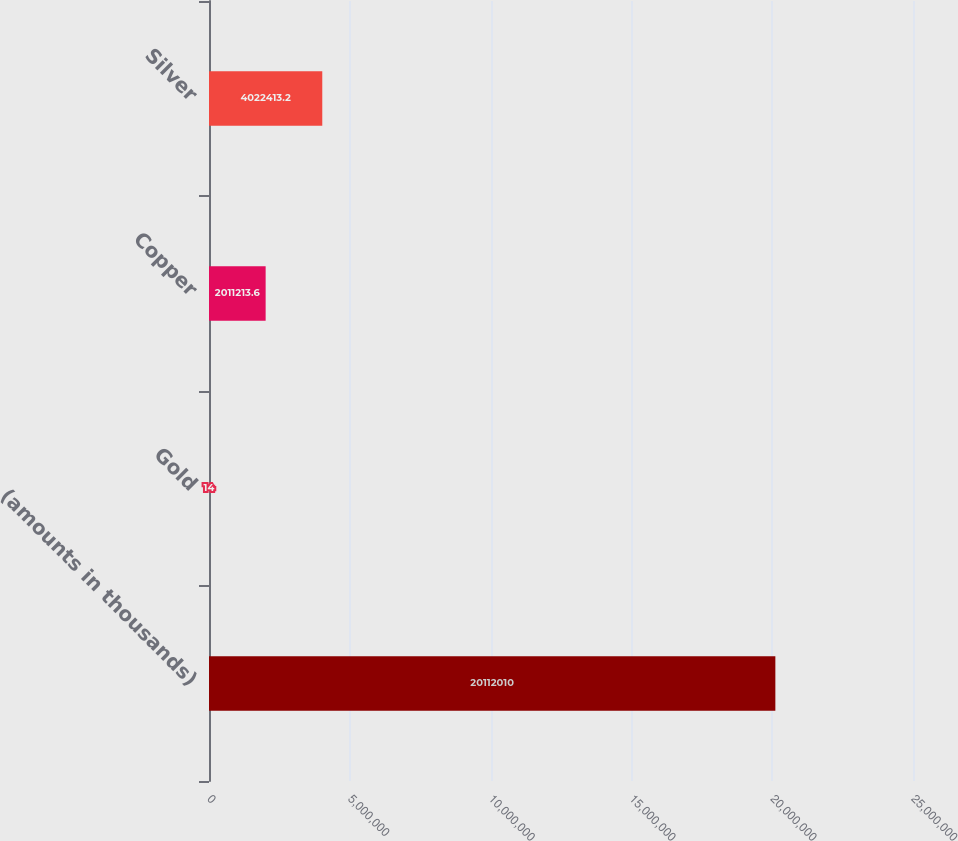Convert chart to OTSL. <chart><loc_0><loc_0><loc_500><loc_500><bar_chart><fcel>(amounts in thousands)<fcel>Gold<fcel>Copper<fcel>Silver<nl><fcel>2.0112e+07<fcel>14<fcel>2.01121e+06<fcel>4.02241e+06<nl></chart> 